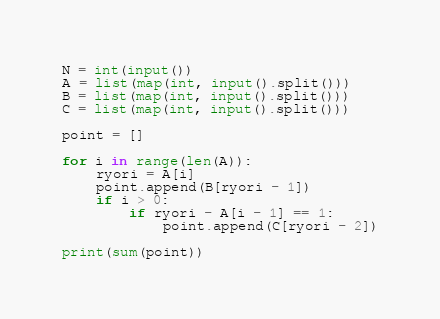Convert code to text. <code><loc_0><loc_0><loc_500><loc_500><_Python_>N = int(input())
A = list(map(int, input().split()))
B = list(map(int, input().split()))
C = list(map(int, input().split()))

point = []

for i in range(len(A)):
    ryori = A[i]
    point.append(B[ryori - 1])
    if i > 0:
        if ryori - A[i - 1] == 1:
            point.append(C[ryori - 2])

print(sum(point))</code> 